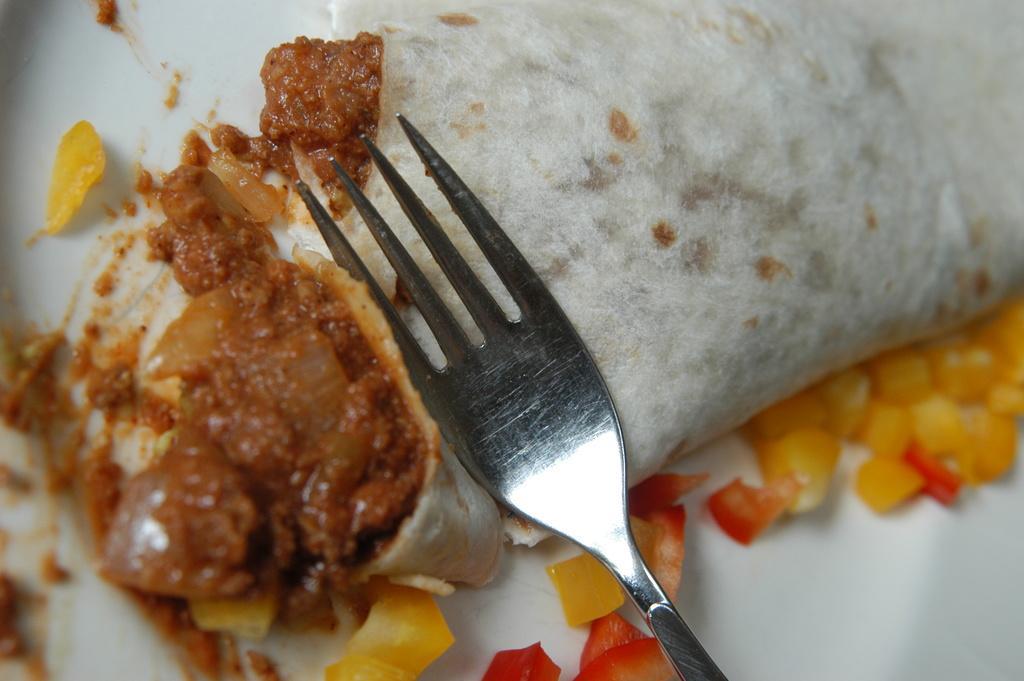How would you summarize this image in a sentence or two? There a fork on an object, on which, there is a curry, near other food items on a white color plate. 